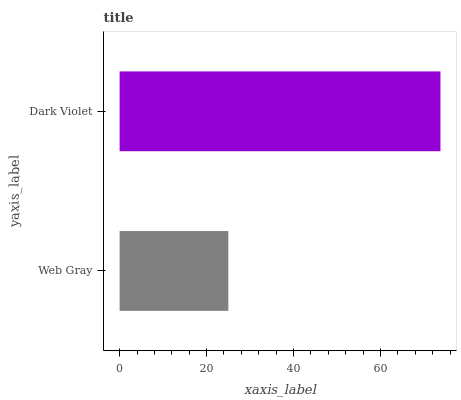Is Web Gray the minimum?
Answer yes or no. Yes. Is Dark Violet the maximum?
Answer yes or no. Yes. Is Dark Violet the minimum?
Answer yes or no. No. Is Dark Violet greater than Web Gray?
Answer yes or no. Yes. Is Web Gray less than Dark Violet?
Answer yes or no. Yes. Is Web Gray greater than Dark Violet?
Answer yes or no. No. Is Dark Violet less than Web Gray?
Answer yes or no. No. Is Dark Violet the high median?
Answer yes or no. Yes. Is Web Gray the low median?
Answer yes or no. Yes. Is Web Gray the high median?
Answer yes or no. No. Is Dark Violet the low median?
Answer yes or no. No. 